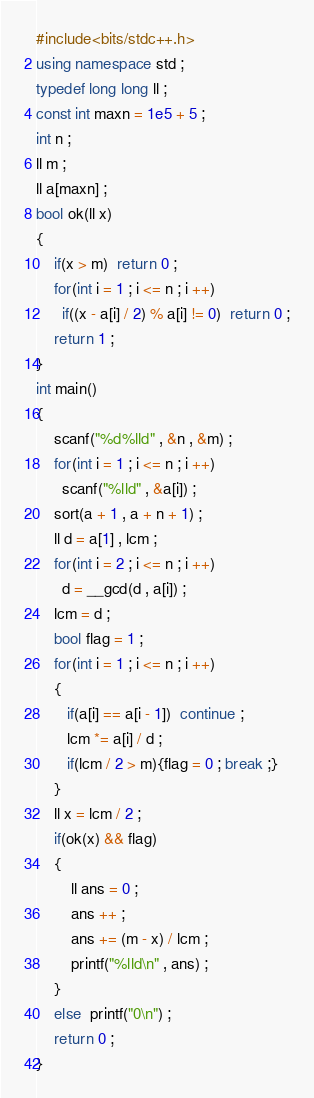Convert code to text. <code><loc_0><loc_0><loc_500><loc_500><_C++_>#include<bits/stdc++.h>
using namespace std ;
typedef long long ll ;
const int maxn = 1e5 + 5 ;
int n ;
ll m ;
ll a[maxn] ;
bool ok(ll x)
{
	if(x > m)  return 0 ;
	for(int i = 1 ; i <= n ; i ++)
	  if((x - a[i] / 2) % a[i] != 0)  return 0 ;
	return 1 ;
}
int main()
{
	scanf("%d%lld" , &n , &m) ;
	for(int i = 1 ; i <= n ; i ++)
	  scanf("%lld" , &a[i]) ;
	sort(a + 1 , a + n + 1) ;
    ll d = a[1] , lcm ;
	for(int i = 2 ; i <= n ; i ++)
	  d = __gcd(d , a[i]) ;
	lcm = d ;
	bool flag = 1 ;
	for(int i = 1 ; i <= n ; i ++)
	{
	   if(a[i] == a[i - 1])  continue ;
	   lcm *= a[i] / d ;
	   if(lcm / 2 > m){flag = 0 ; break ;}
	}	
	ll x = lcm / 2 ;
	if(ok(x) && flag)
	{
		ll ans = 0 ;
		ans ++ ;
		ans += (m - x) / lcm ;
		printf("%lld\n" , ans) ;
	}
	else  printf("0\n") ;
	return 0 ;
}</code> 